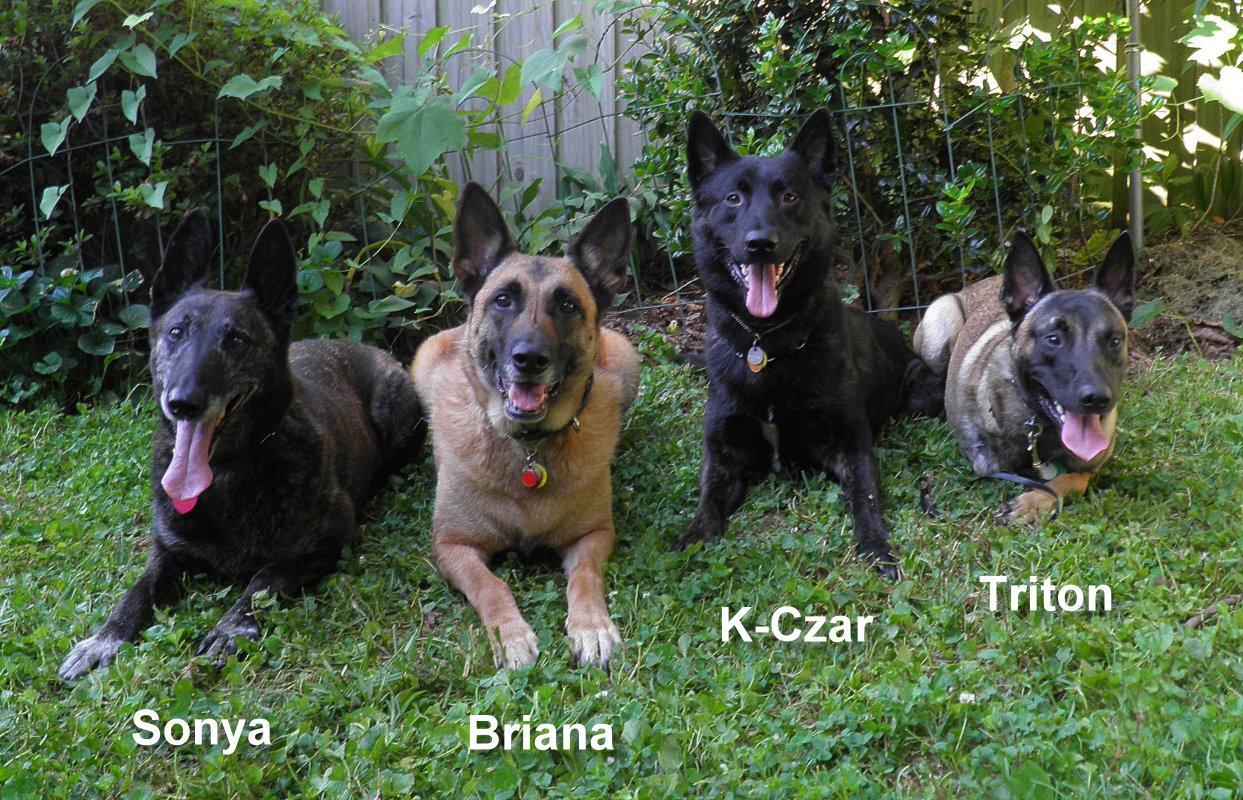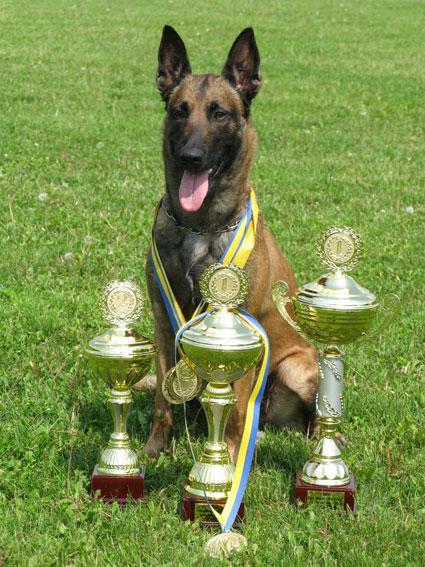The first image is the image on the left, the second image is the image on the right. Evaluate the accuracy of this statement regarding the images: "An image shows exactly one german shepherd, which is sitting on the grass.". Is it true? Answer yes or no. Yes. 